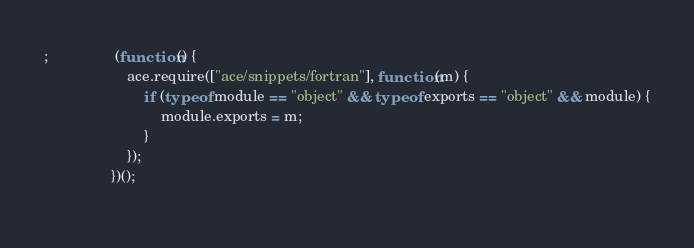Convert code to text. <code><loc_0><loc_0><loc_500><loc_500><_JavaScript_>
;                (function() {
                    ace.require(["ace/snippets/fortran"], function(m) {
                        if (typeof module == "object" && typeof exports == "object" && module) {
                            module.exports = m;
                        }
                    });
                })();
            </code> 